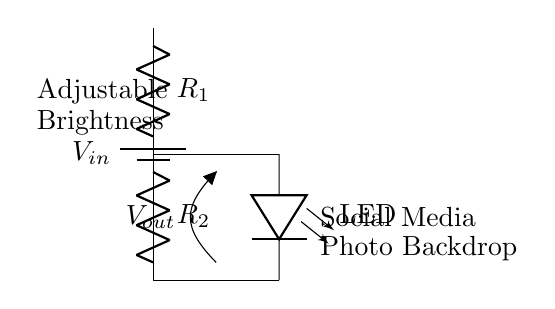What is the power supply voltage in this circuit? The circuit shows a battery labeled as $V_{in}$, but the exact voltage value isn't specified in the diagram. However, it indicates that a voltage source is present to power the circuit.
Answer: Vin What do the resistors $R_1$ and $R_2$ control in this circuit? In a voltage divider, resistors $R_1$ and $R_2$ determine the output voltage across the output point $V_{out}$. The ratio of these resistors dictates how much voltage is dropped across each resistor, thereby adjusting the brightness of the LED.
Answer: Brightness How is the LED connected in the circuit? The LED is connected in parallel to the output voltage node $V_{out}$, which means it receives the voltage determined by the voltage divider formed by resistors $R_1$ and $R_2$.
Answer: In parallel What does $V_{out}$ represent in this circuit? $V_{out}$ represents the voltage across the LED, which is the output voltage of the voltage divider. This voltage directly affects the brightness of the LED, illuminating it to the desired level for social media photography.
Answer: Output voltage How would increasing $R_1$ affect the LED brightness? Increasing $R_1$ increases the resistance at the top of the voltage divider, resulting in a higher voltage drop across $R_2$. This causes $V_{out}$ to decrease, which typically reduces the current through the LED, thus dimming its brightness.
Answer: Dims brightness What is the purpose of using a voltage divider in this circuit? The voltage divider adjusts the voltage level at $V_{out}$ for driving the LED, allowing for customization of LED brightness according to different lighting conditions in social media photo backdrops.
Answer: Adjust brightness 